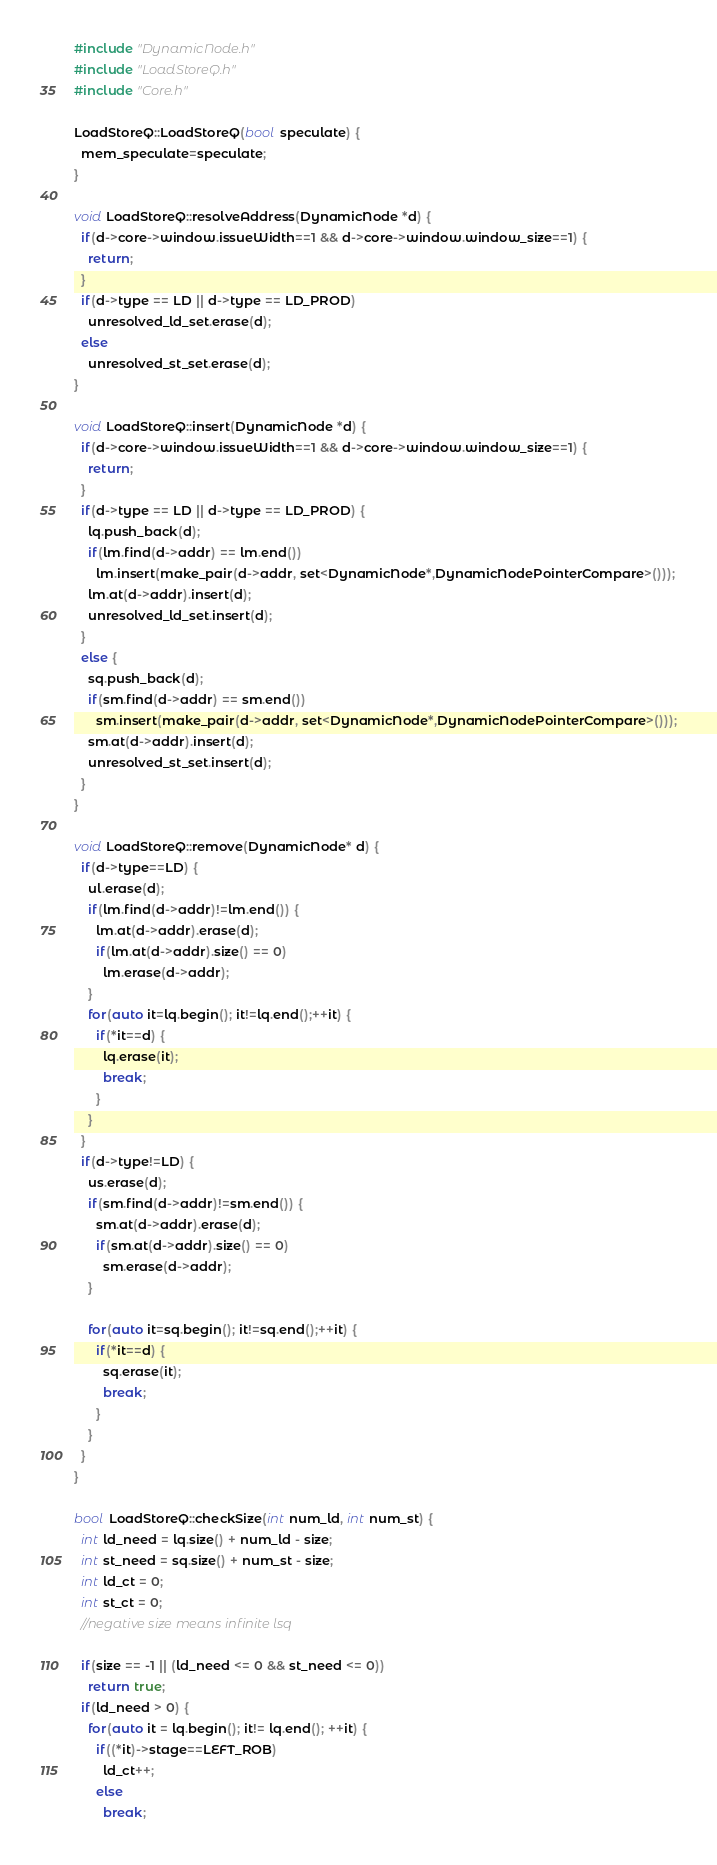<code> <loc_0><loc_0><loc_500><loc_500><_C++_>#include "DynamicNode.h"
#include "LoadStoreQ.h"
#include "Core.h"

LoadStoreQ::LoadStoreQ(bool speculate) {
  mem_speculate=speculate;
}

void LoadStoreQ::resolveAddress(DynamicNode *d) {
  if(d->core->window.issueWidth==1 && d->core->window.window_size==1) {
    return;
  }
  if(d->type == LD || d->type == LD_PROD)
    unresolved_ld_set.erase(d);
  else
    unresolved_st_set.erase(d);
}

void LoadStoreQ::insert(DynamicNode *d) {
  if(d->core->window.issueWidth==1 && d->core->window.window_size==1) {
    return;
  }
  if(d->type == LD || d->type == LD_PROD) {
    lq.push_back(d);
    if(lm.find(d->addr) == lm.end())
      lm.insert(make_pair(d->addr, set<DynamicNode*,DynamicNodePointerCompare>()));
    lm.at(d->addr).insert(d);
    unresolved_ld_set.insert(d);
  }
  else {
    sq.push_back(d);
    if(sm.find(d->addr) == sm.end())
      sm.insert(make_pair(d->addr, set<DynamicNode*,DynamicNodePointerCompare>()));
    sm.at(d->addr).insert(d);
    unresolved_st_set.insert(d);
  }
}

void LoadStoreQ::remove(DynamicNode* d) {
  if(d->type==LD) {
    ul.erase(d);
    if(lm.find(d->addr)!=lm.end()) {
      lm.at(d->addr).erase(d);
      if(lm.at(d->addr).size() == 0)
        lm.erase(d->addr);
    }
    for(auto it=lq.begin(); it!=lq.end();++it) {
      if(*it==d) {
        lq.erase(it);
        break;
      }
    }
  }
  if(d->type!=LD) {
    us.erase(d);
    if(sm.find(d->addr)!=sm.end()) {
      sm.at(d->addr).erase(d);
      if(sm.at(d->addr).size() == 0)
        sm.erase(d->addr);
    }

    for(auto it=sq.begin(); it!=sq.end();++it) {
      if(*it==d) {
        sq.erase(it);
        break;
      }
    }
  }
}

bool LoadStoreQ::checkSize(int num_ld, int num_st) {
  int ld_need = lq.size() + num_ld - size;
  int st_need = sq.size() + num_st - size;
  int ld_ct = 0;
  int st_ct = 0;
  //negative size means infinite lsq

  if(size == -1 || (ld_need <= 0 && st_need <= 0))
    return true;
  if(ld_need > 0) {
    for(auto it = lq.begin(); it!= lq.end(); ++it) {
      if((*it)->stage==LEFT_ROB)
        ld_ct++;
      else
        break;</code> 